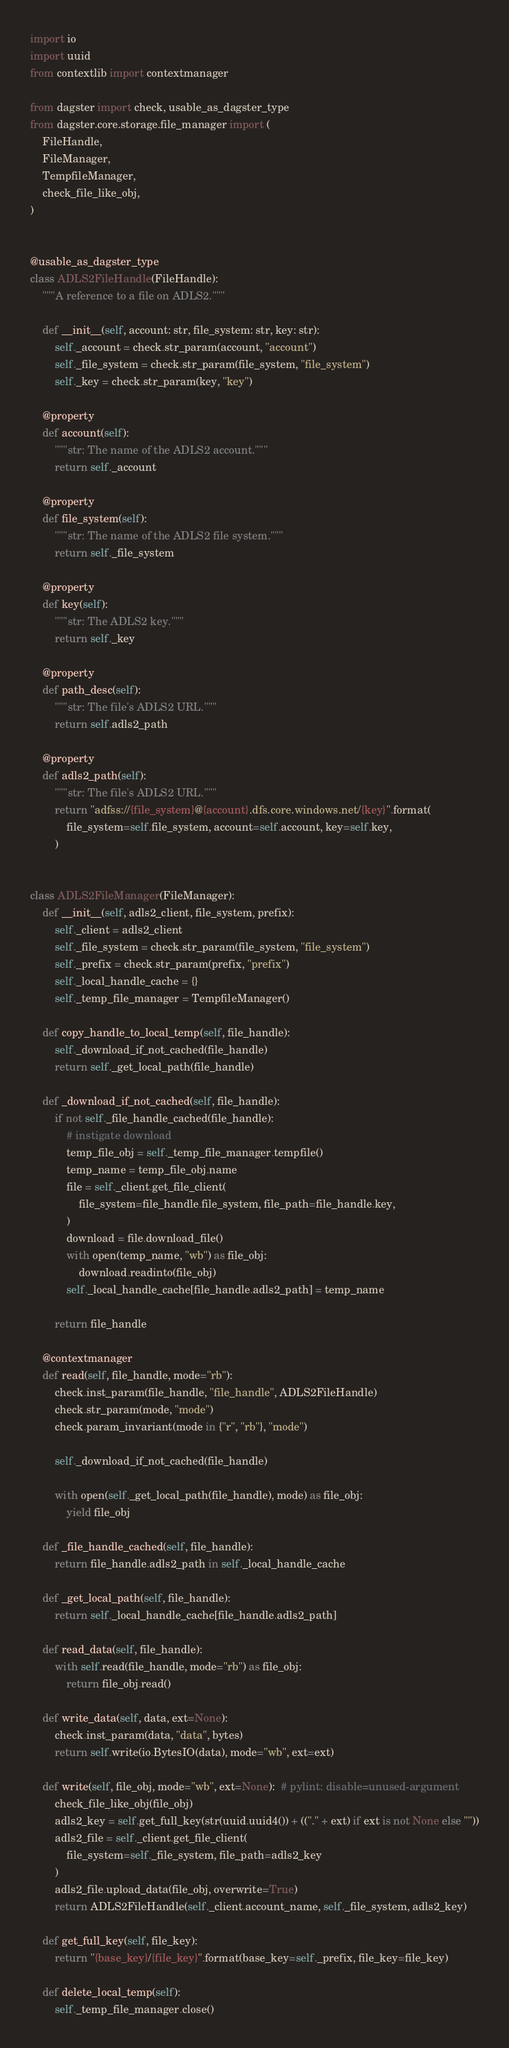Convert code to text. <code><loc_0><loc_0><loc_500><loc_500><_Python_>import io
import uuid
from contextlib import contextmanager

from dagster import check, usable_as_dagster_type
from dagster.core.storage.file_manager import (
    FileHandle,
    FileManager,
    TempfileManager,
    check_file_like_obj,
)


@usable_as_dagster_type
class ADLS2FileHandle(FileHandle):
    """A reference to a file on ADLS2."""

    def __init__(self, account: str, file_system: str, key: str):
        self._account = check.str_param(account, "account")
        self._file_system = check.str_param(file_system, "file_system")
        self._key = check.str_param(key, "key")

    @property
    def account(self):
        """str: The name of the ADLS2 account."""
        return self._account

    @property
    def file_system(self):
        """str: The name of the ADLS2 file system."""
        return self._file_system

    @property
    def key(self):
        """str: The ADLS2 key."""
        return self._key

    @property
    def path_desc(self):
        """str: The file's ADLS2 URL."""
        return self.adls2_path

    @property
    def adls2_path(self):
        """str: The file's ADLS2 URL."""
        return "adfss://{file_system}@{account}.dfs.core.windows.net/{key}".format(
            file_system=self.file_system, account=self.account, key=self.key,
        )


class ADLS2FileManager(FileManager):
    def __init__(self, adls2_client, file_system, prefix):
        self._client = adls2_client
        self._file_system = check.str_param(file_system, "file_system")
        self._prefix = check.str_param(prefix, "prefix")
        self._local_handle_cache = {}
        self._temp_file_manager = TempfileManager()

    def copy_handle_to_local_temp(self, file_handle):
        self._download_if_not_cached(file_handle)
        return self._get_local_path(file_handle)

    def _download_if_not_cached(self, file_handle):
        if not self._file_handle_cached(file_handle):
            # instigate download
            temp_file_obj = self._temp_file_manager.tempfile()
            temp_name = temp_file_obj.name
            file = self._client.get_file_client(
                file_system=file_handle.file_system, file_path=file_handle.key,
            )
            download = file.download_file()
            with open(temp_name, "wb") as file_obj:
                download.readinto(file_obj)
            self._local_handle_cache[file_handle.adls2_path] = temp_name

        return file_handle

    @contextmanager
    def read(self, file_handle, mode="rb"):
        check.inst_param(file_handle, "file_handle", ADLS2FileHandle)
        check.str_param(mode, "mode")
        check.param_invariant(mode in {"r", "rb"}, "mode")

        self._download_if_not_cached(file_handle)

        with open(self._get_local_path(file_handle), mode) as file_obj:
            yield file_obj

    def _file_handle_cached(self, file_handle):
        return file_handle.adls2_path in self._local_handle_cache

    def _get_local_path(self, file_handle):
        return self._local_handle_cache[file_handle.adls2_path]

    def read_data(self, file_handle):
        with self.read(file_handle, mode="rb") as file_obj:
            return file_obj.read()

    def write_data(self, data, ext=None):
        check.inst_param(data, "data", bytes)
        return self.write(io.BytesIO(data), mode="wb", ext=ext)

    def write(self, file_obj, mode="wb", ext=None):  # pylint: disable=unused-argument
        check_file_like_obj(file_obj)
        adls2_key = self.get_full_key(str(uuid.uuid4()) + (("." + ext) if ext is not None else ""))
        adls2_file = self._client.get_file_client(
            file_system=self._file_system, file_path=adls2_key
        )
        adls2_file.upload_data(file_obj, overwrite=True)
        return ADLS2FileHandle(self._client.account_name, self._file_system, adls2_key)

    def get_full_key(self, file_key):
        return "{base_key}/{file_key}".format(base_key=self._prefix, file_key=file_key)

    def delete_local_temp(self):
        self._temp_file_manager.close()
</code> 